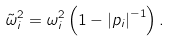<formula> <loc_0><loc_0><loc_500><loc_500>\tilde { \omega } _ { i } ^ { 2 } = \omega _ { i } ^ { 2 } \left ( 1 - \left | p _ { i } \right | ^ { - 1 } \right ) .</formula> 